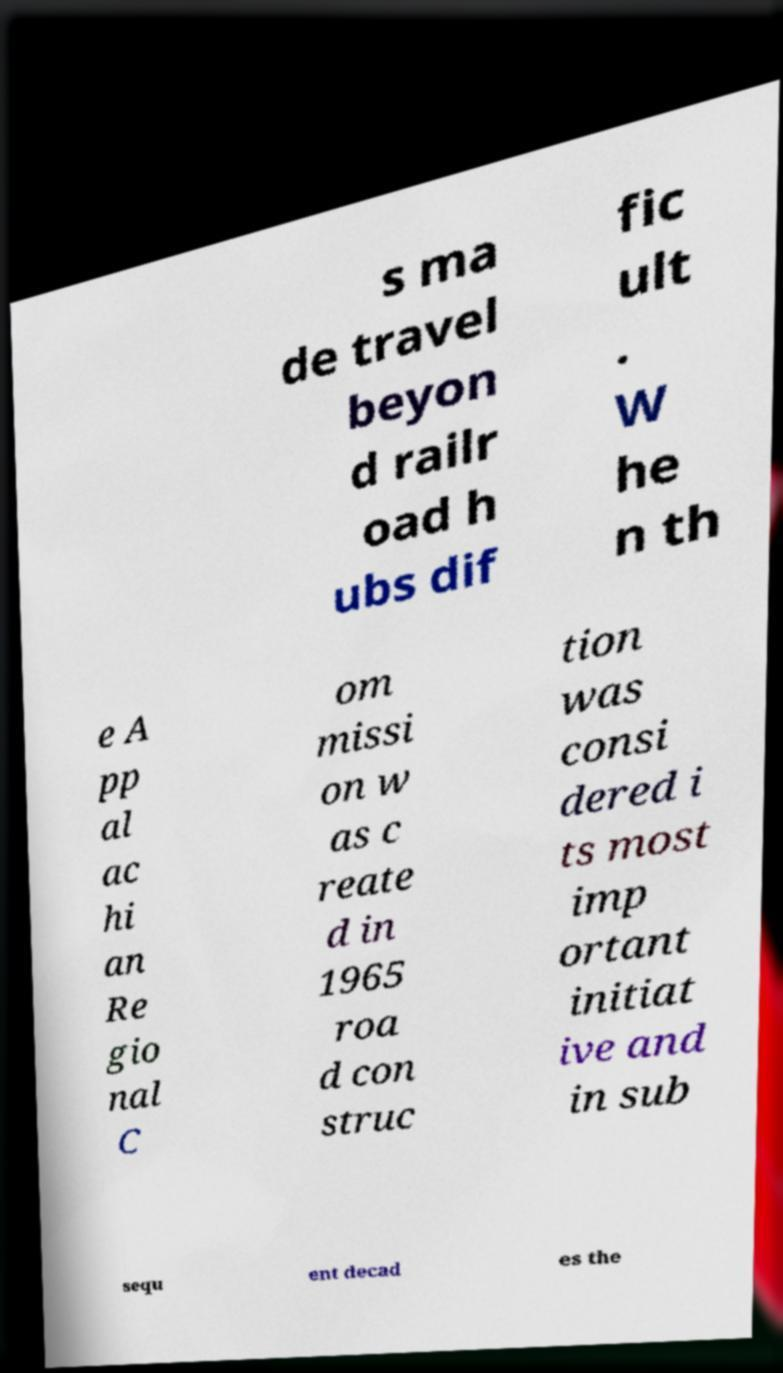What messages or text are displayed in this image? I need them in a readable, typed format. s ma de travel beyon d railr oad h ubs dif fic ult . W he n th e A pp al ac hi an Re gio nal C om missi on w as c reate d in 1965 roa d con struc tion was consi dered i ts most imp ortant initiat ive and in sub sequ ent decad es the 